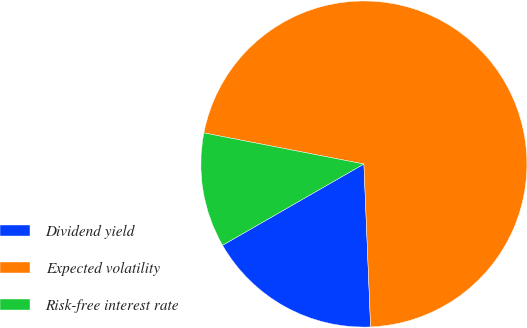Convert chart to OTSL. <chart><loc_0><loc_0><loc_500><loc_500><pie_chart><fcel>Dividend yield<fcel>Expected volatility<fcel>Risk-free interest rate<nl><fcel>17.35%<fcel>71.29%<fcel>11.36%<nl></chart> 